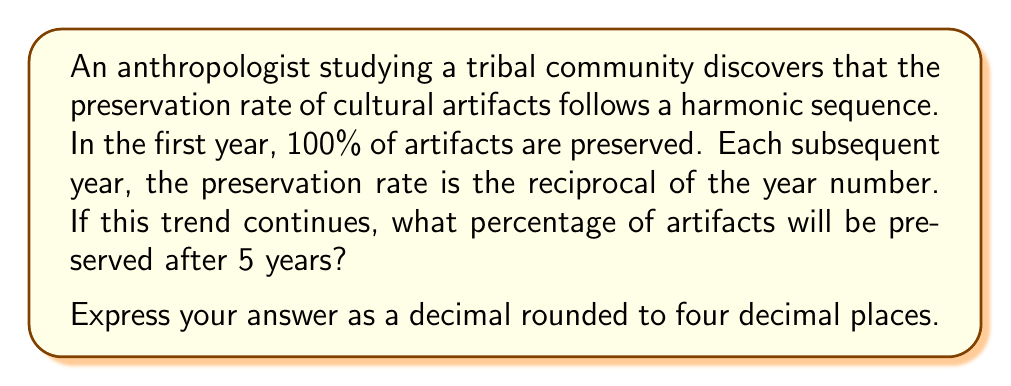Teach me how to tackle this problem. Let's approach this step-by-step:

1) The harmonic sequence for preservation rates is:

   Year 1: $\frac{1}{1} = 100\%$
   Year 2: $\frac{1}{2} = 50\%$
   Year 3: $\frac{1}{3} \approx 33.33\%$
   Year 4: $\frac{1}{4} = 25\%$
   Year 5: $\frac{1}{5} = 20\%$

2) To find the total preservation rate after 5 years, we need to multiply these percentages:

   $$\frac{1}{1} \cdot \frac{1}{2} \cdot \frac{1}{3} \cdot \frac{1}{4} \cdot \frac{1}{5}$$

3) This can be simplified to:

   $$\frac{1}{1 \cdot 2 \cdot 3 \cdot 4 \cdot 5} = \frac{1}{5!} = \frac{1}{120}$$

4) Converting to a decimal:

   $$\frac{1}{120} \approx 0.008333333...$$

5) Rounding to four decimal places:

   $$0.0083$$

Therefore, after 5 years, approximately 0.0083 or 0.83% of the artifacts will be preserved.
Answer: 0.0083 